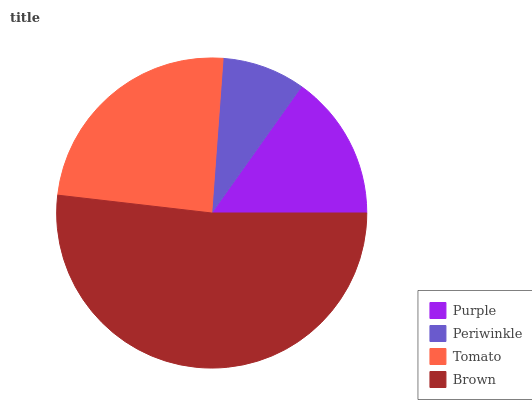Is Periwinkle the minimum?
Answer yes or no. Yes. Is Brown the maximum?
Answer yes or no. Yes. Is Tomato the minimum?
Answer yes or no. No. Is Tomato the maximum?
Answer yes or no. No. Is Tomato greater than Periwinkle?
Answer yes or no. Yes. Is Periwinkle less than Tomato?
Answer yes or no. Yes. Is Periwinkle greater than Tomato?
Answer yes or no. No. Is Tomato less than Periwinkle?
Answer yes or no. No. Is Tomato the high median?
Answer yes or no. Yes. Is Purple the low median?
Answer yes or no. Yes. Is Periwinkle the high median?
Answer yes or no. No. Is Brown the low median?
Answer yes or no. No. 